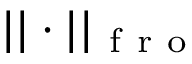<formula> <loc_0><loc_0><loc_500><loc_500>| | \cdot | | _ { f r o }</formula> 